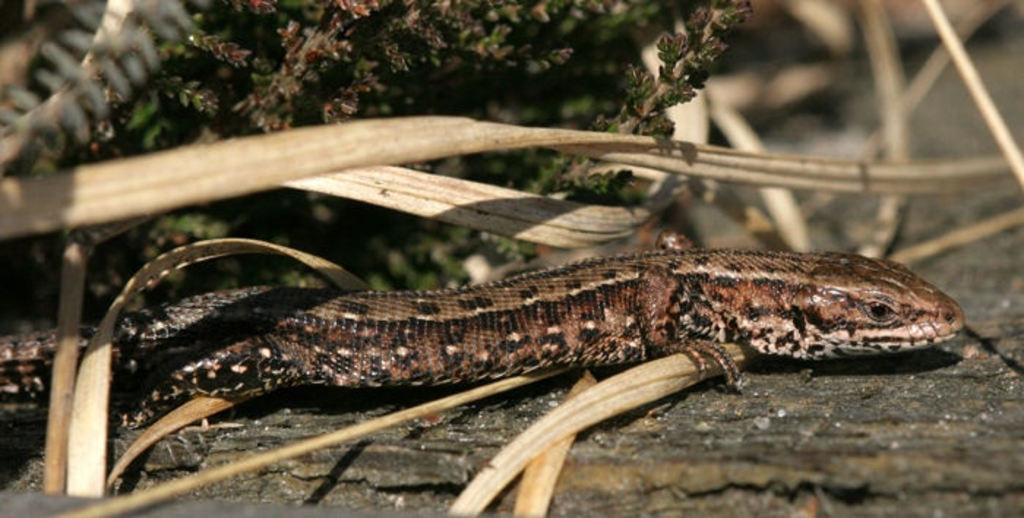What type of vegetation can be seen in the image? There are leaves in the image. What animal is present in the image? There is a brown-colored lizard in the center of the image. How many toes does the lizard have on its left foot in the image? There is no way to determine the number of toes on the lizard's left foot from the image, as it is not visible. 